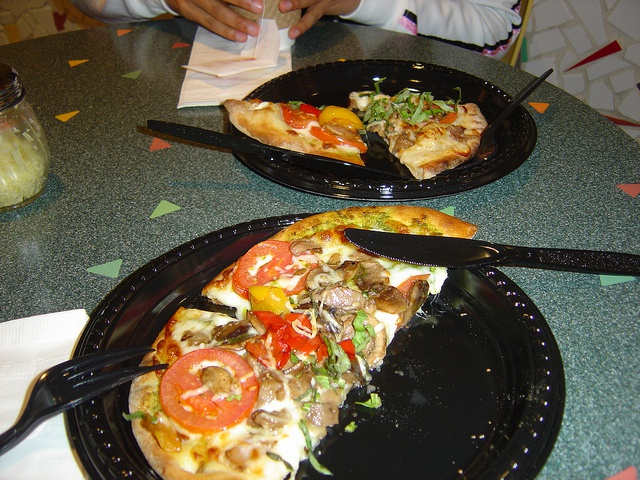Describe the objects in this image and their specific colors. I can see dining table in black, gray, darkgreen, and ivory tones, pizza in darkgreen, tan, khaki, olive, and ivory tones, people in darkgreen, darkgray, brown, gray, and maroon tones, chair in darkgreen, gray, maroon, olive, and black tones, and pizza in darkgreen, olive, and tan tones in this image. 